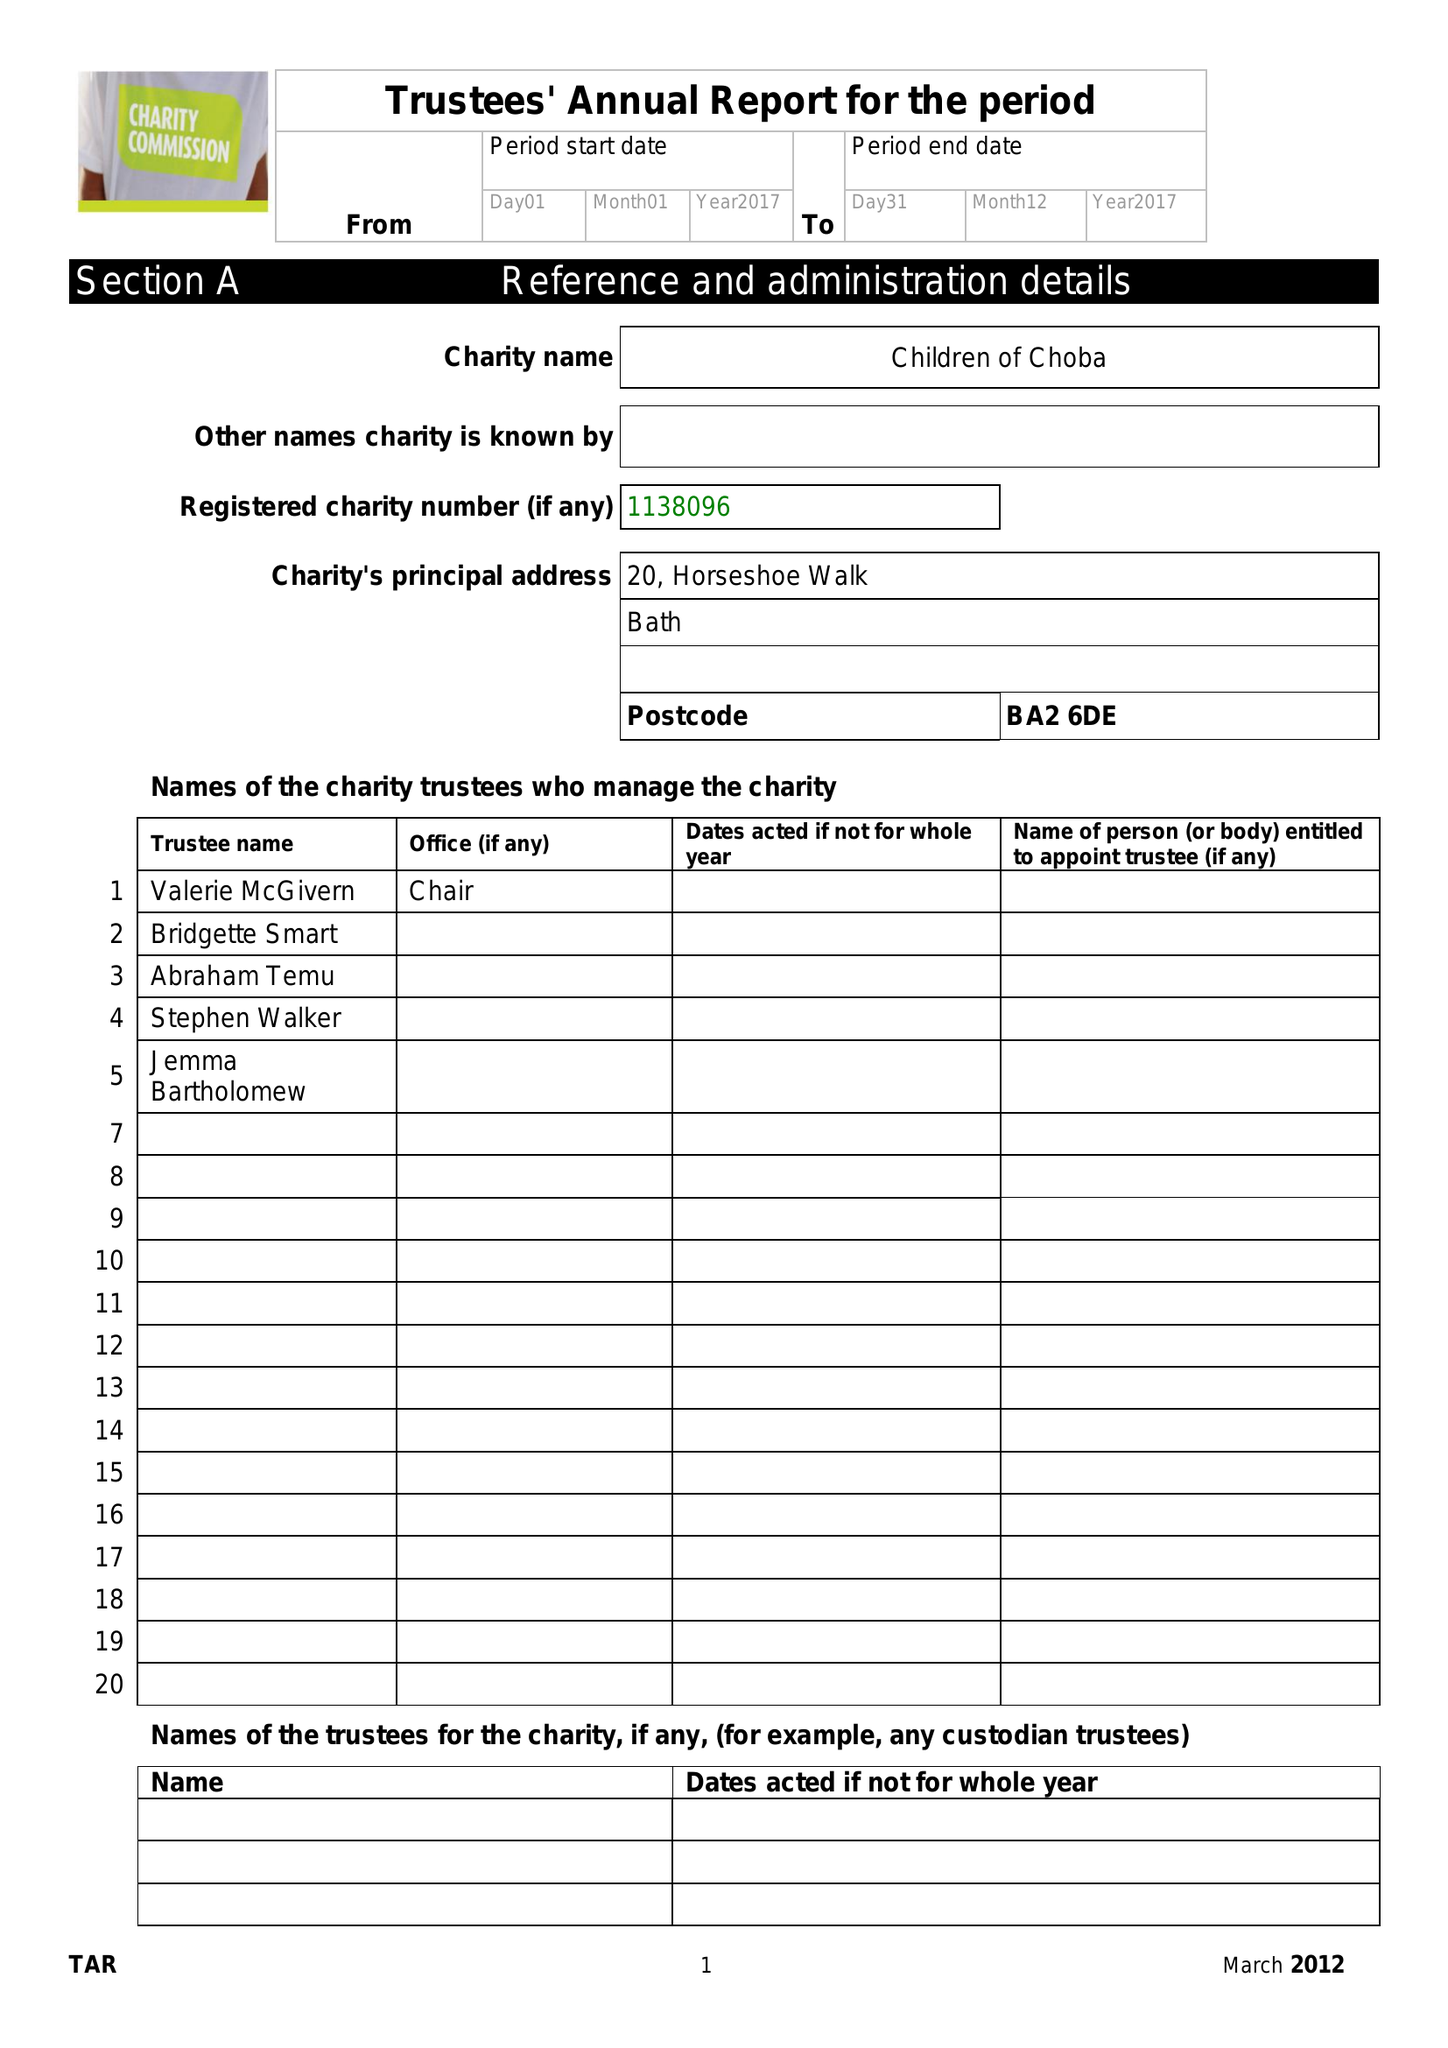What is the value for the address__post_town?
Answer the question using a single word or phrase. BATH 